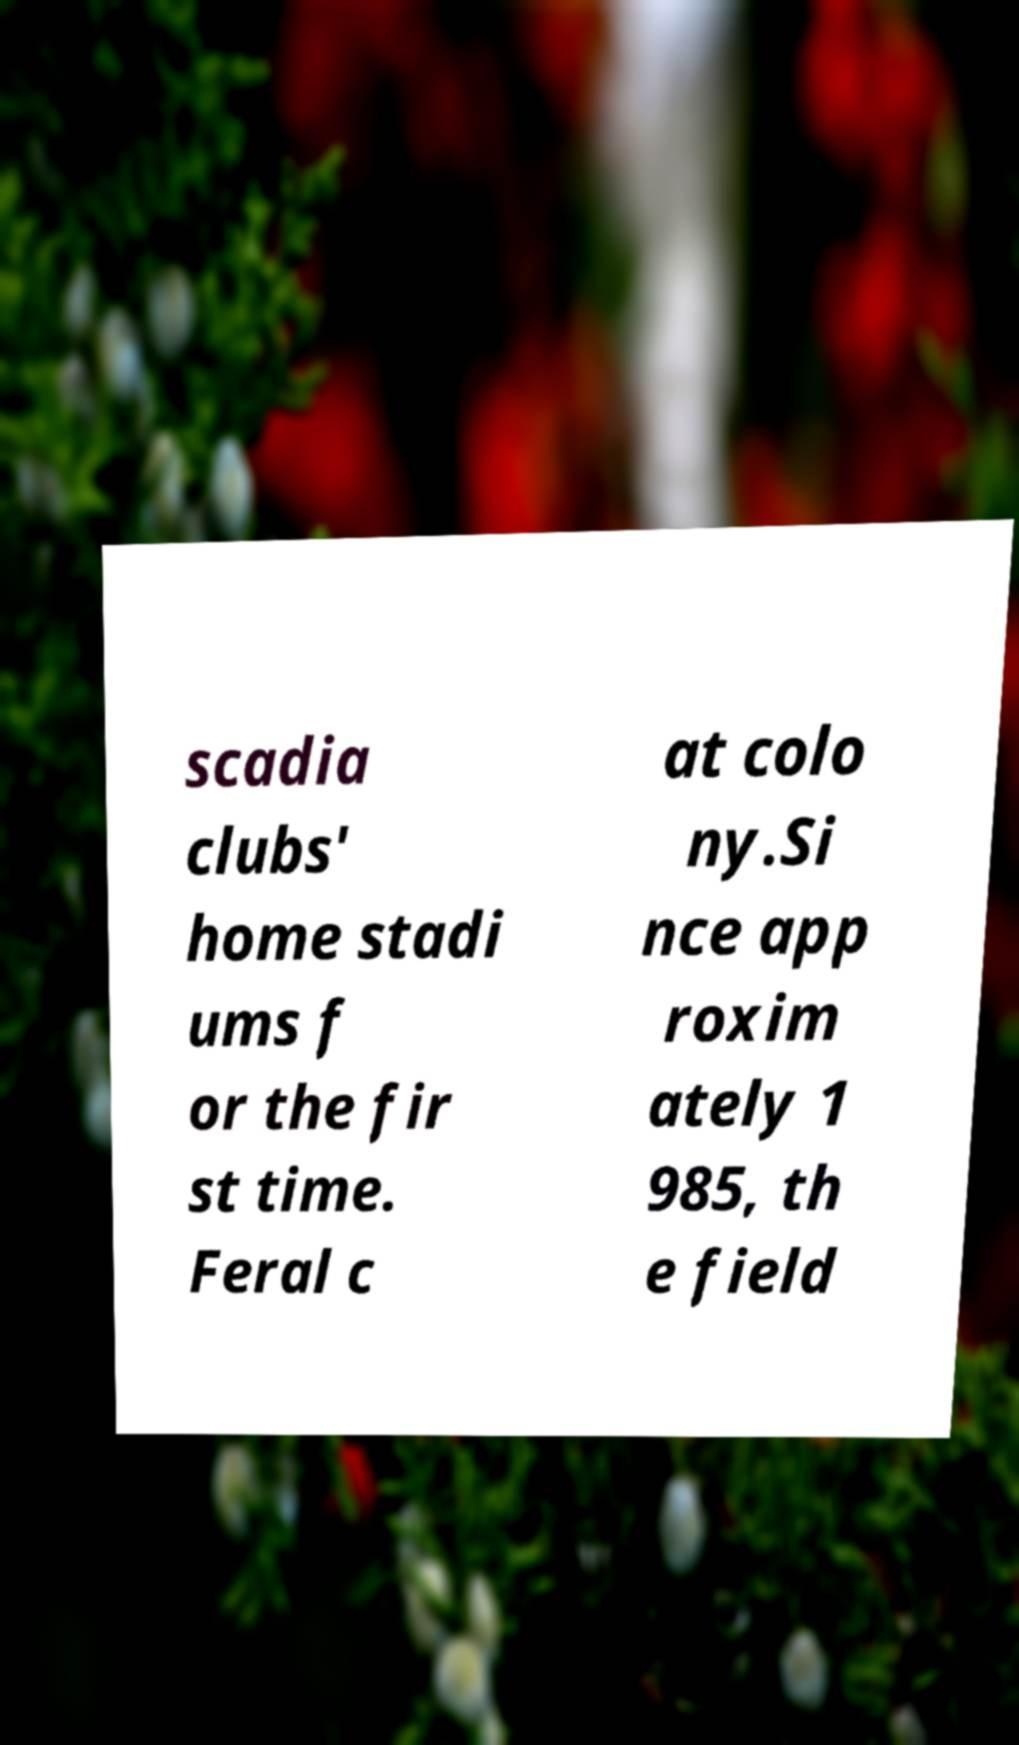For documentation purposes, I need the text within this image transcribed. Could you provide that? scadia clubs' home stadi ums f or the fir st time. Feral c at colo ny.Si nce app roxim ately 1 985, th e field 